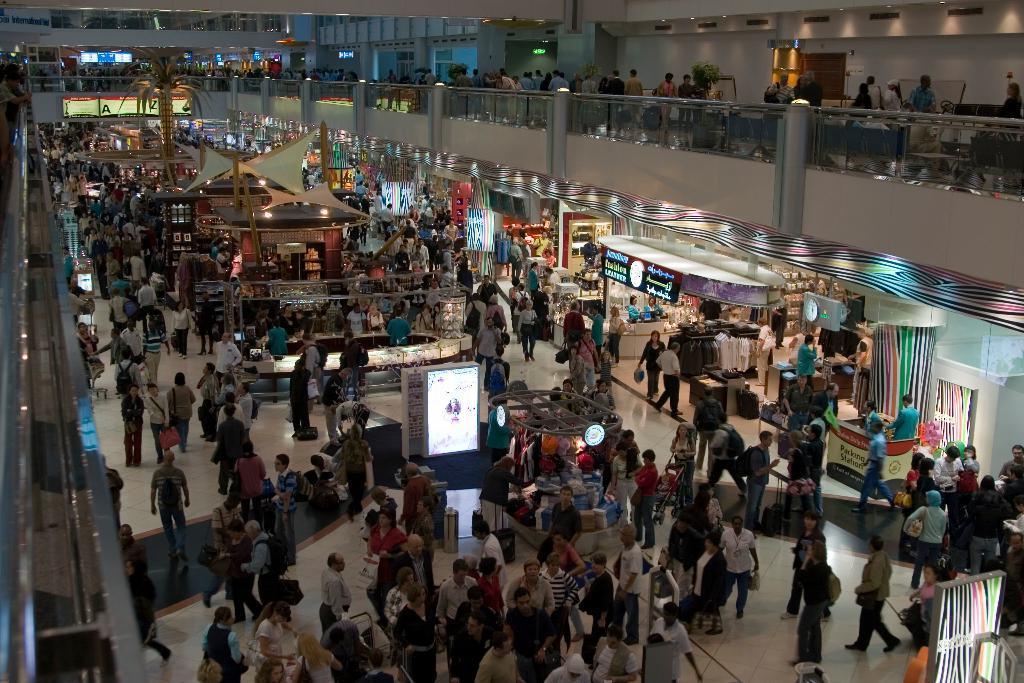How would you summarize this image in a sentence or two? In this image we can see persons, stores, advertisements, cloth, lights, tree, stairs, pillars, doors and wall. 